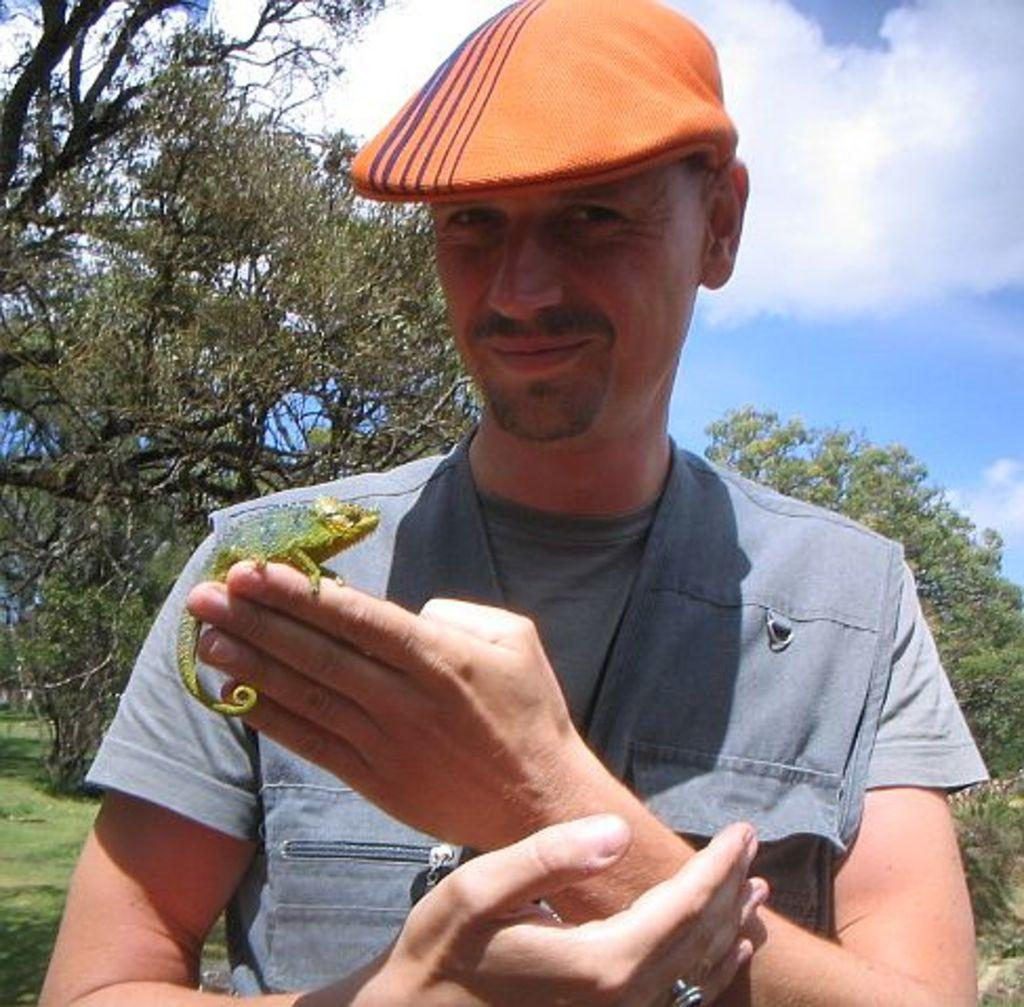What is on the person's hand in the image? There is an animal on the person's hand in the image. What can be seen in the background of the image? There is a group of trees in the background of the image. How would you describe the sky in the image? The sky is cloudy in the image. How many mice are playing on the waves in the image? There are no mice or waves present in the image. 